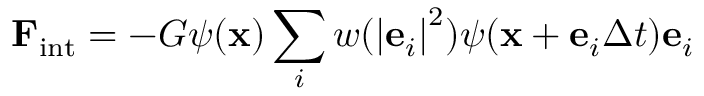<formula> <loc_0><loc_0><loc_500><loc_500>{ { F } _ { i n t } } = - G \psi ( { x } ) \sum _ { i } { w ( { { \left | { { { e } _ { i } } } \right | } ^ { 2 } } ) } \psi ( { x } + { { e } _ { i } } \Delta t ) { { e } _ { i } }</formula> 